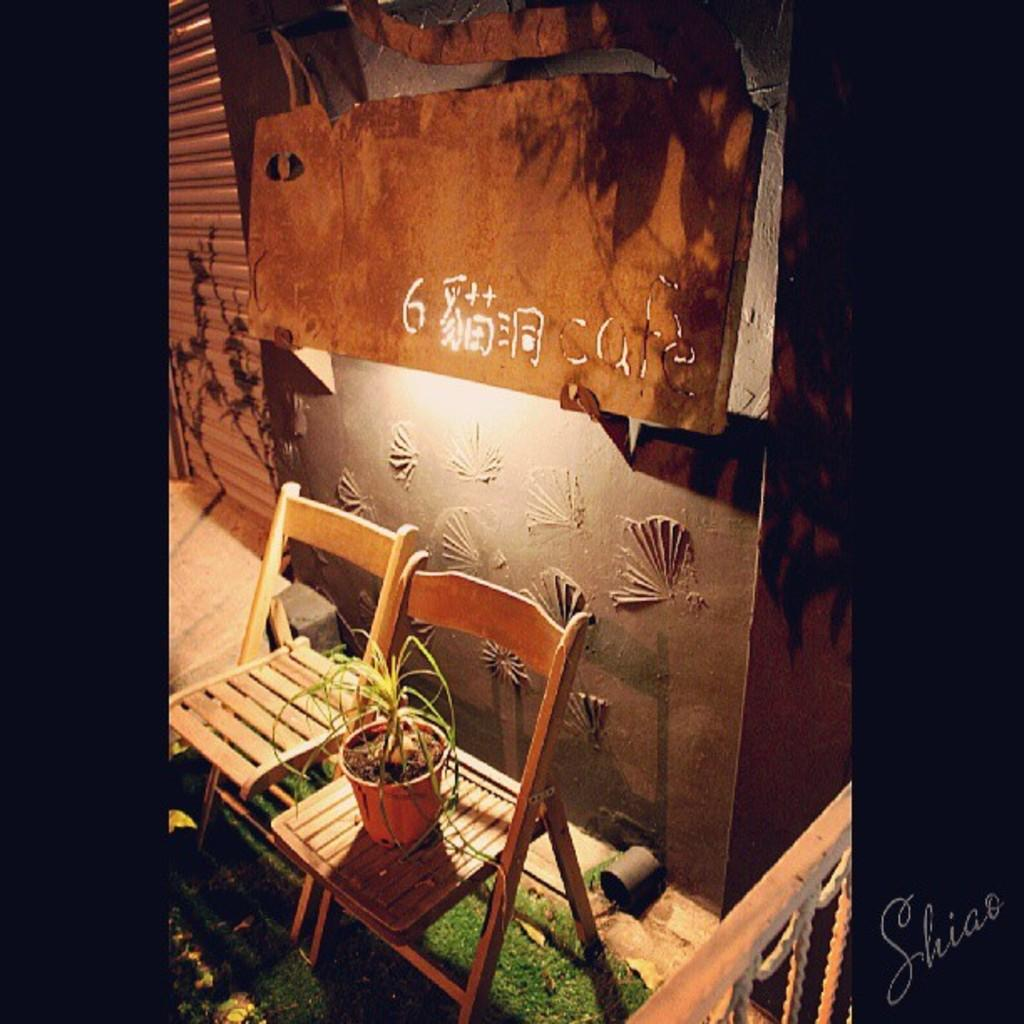How many chairs are visible in the image? There are two chairs in the image. What is placed on one of the chairs? A flower pot is present on one of the chairs. Where are the chairs and flower pot located? They are on grass in the image. What architectural features can be seen in the image? There is a shutter, a wall, and a fence in the image. What other object is visible in the image? There is a pipe in the image. What type of music can be heard coming from the chairs in the image? There is no music present in the image; it only features chairs, a flower pot, grass, and other architectural elements. 